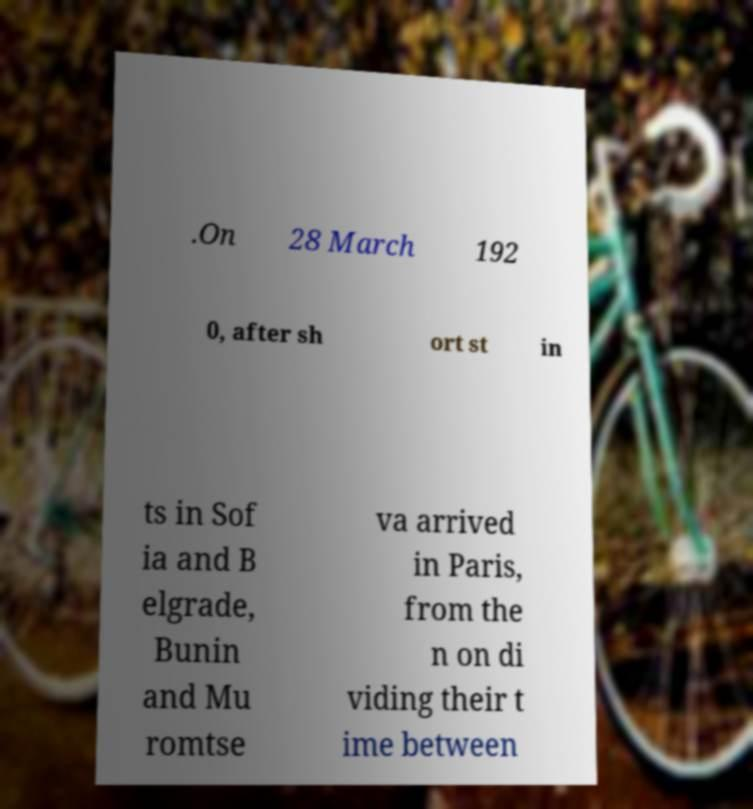Please read and relay the text visible in this image. What does it say? .On 28 March 192 0, after sh ort st in ts in Sof ia and B elgrade, Bunin and Mu romtse va arrived in Paris, from the n on di viding their t ime between 